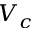<formula> <loc_0><loc_0><loc_500><loc_500>V _ { c }</formula> 